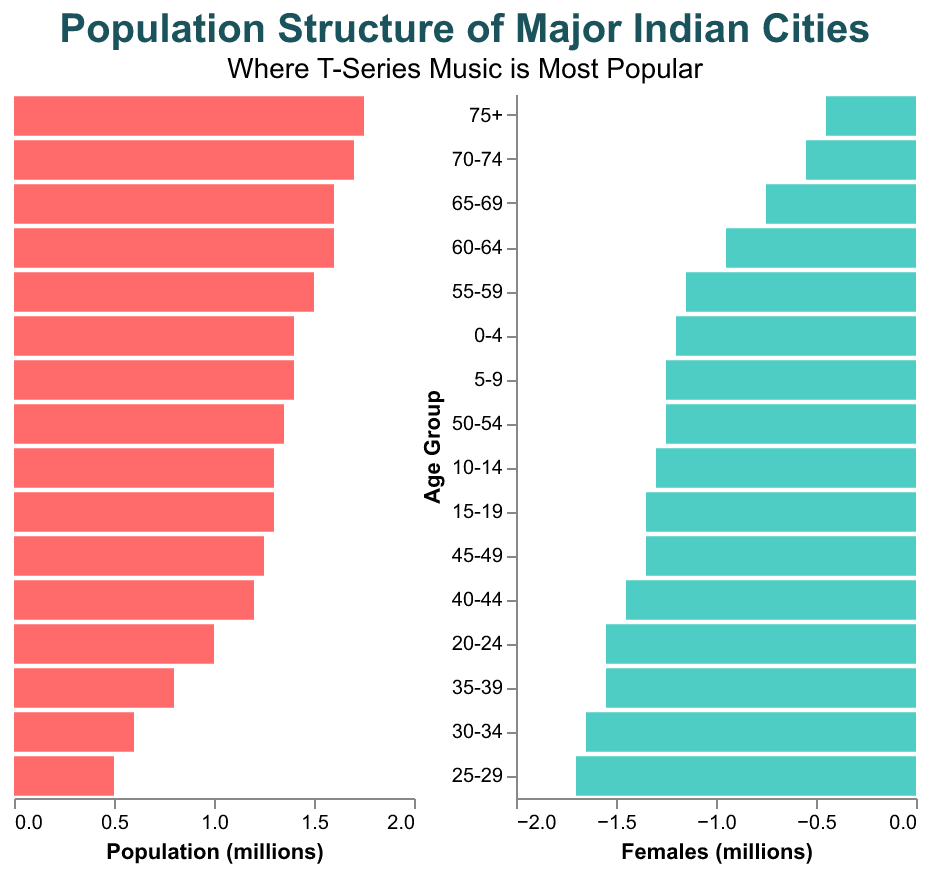How is the population distributed across different age groups? The bars on the population pyramid display the number of males and females across various age groups. Both sides show a larger population in the younger age groups with the numbers gradually decreasing as the age group increases.
Answer: Younger age groups have higher populations What is the population of males in the 20-24 age group? The bar for males in the 20-24 age group shows a value of 1.6 million.
Answer: 1.6 million Which gender has more population in the age group 25-29? By comparing the bars for males and females in the 25-29 age group, it can be seen that males have a slightly higher population than females.
Answer: Males How does the population of females change from age group 5-9 to 10-14? The population of females increases from 1.25 million in the 5-9 age group to 1.3 million in the 10-14 age group, indicating an increase of 50,000.
Answer: Increases by 50,000 What is the total population of people aged 75 and above? Both male and female populations in the 75+ age group need to be summed up: 500,000 (males) + 450,000 (females) = 950,000.
Answer: 950,000 In which age group do both males and females have the same population? By scanning the bars on either side of the pyramid, we can see that none of the age groups has an exact equal population of males and females.
Answer: None Compare the male population in the 30-34 age group with the female population in the same group. Who is larger and by how much? The male population is 1.7 million whereas the female population is 1.65 million in the 30-34 age group. Hence, the male population is larger by 50,000.
Answer: Males by 50,000 What is the average population of males in the age groups 60-64, 65-69, and 70-74? Summing up the male populations in these groups (1,000,000, 800,000, 600,000), we get 2,400,000. Dividing by 3 gives us 800,000.
Answer: 800,000 